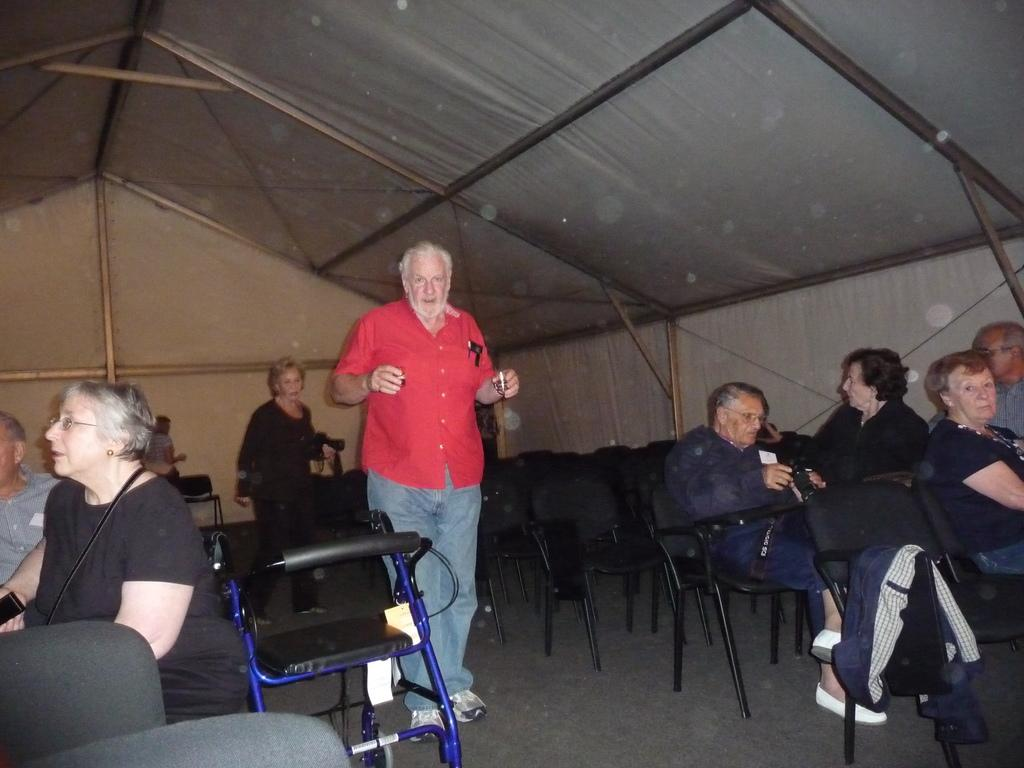Who can be seen in the middle of the image? There is a man and a woman in the middle of the image. What are the man and woman doing? The man and woman are walking. What can be seen on either side of the image? There are persons sitting on either side of the image. What type of structure is visible in the background? The setting appears to be a shed. What type of pig can be seen in the wilderness in the image? There is no pig or wilderness present in the image; it features a man and a woman walking in a shed setting. What type of disease is affecting the persons sitting on either side of the image? There is no indication of any disease affecting the persons in the image; they are simply sitting. 